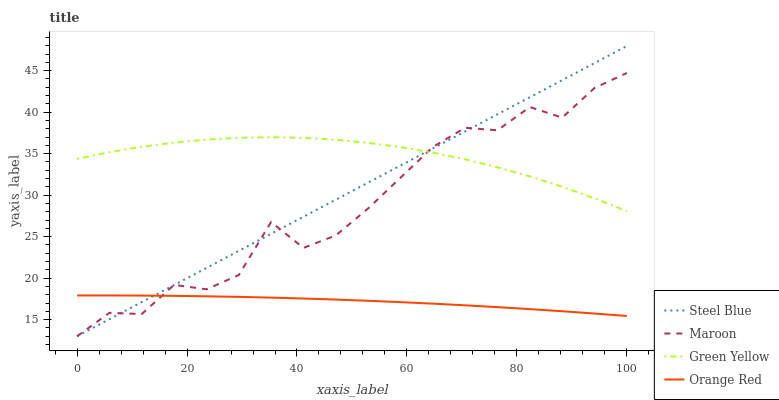Does Orange Red have the minimum area under the curve?
Answer yes or no. Yes. Does Green Yellow have the maximum area under the curve?
Answer yes or no. Yes. Does Steel Blue have the minimum area under the curve?
Answer yes or no. No. Does Steel Blue have the maximum area under the curve?
Answer yes or no. No. Is Steel Blue the smoothest?
Answer yes or no. Yes. Is Maroon the roughest?
Answer yes or no. Yes. Is Maroon the smoothest?
Answer yes or no. No. Is Steel Blue the roughest?
Answer yes or no. No. Does Orange Red have the lowest value?
Answer yes or no. No. Does Steel Blue have the highest value?
Answer yes or no. Yes. Does Maroon have the highest value?
Answer yes or no. No. Is Orange Red less than Green Yellow?
Answer yes or no. Yes. Is Green Yellow greater than Orange Red?
Answer yes or no. Yes. Does Maroon intersect Steel Blue?
Answer yes or no. Yes. Is Maroon less than Steel Blue?
Answer yes or no. No. Is Maroon greater than Steel Blue?
Answer yes or no. No. Does Orange Red intersect Green Yellow?
Answer yes or no. No. 